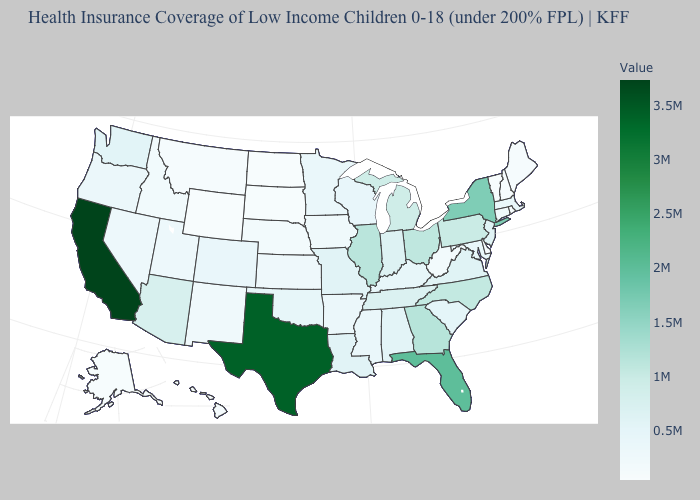Among the states that border Oregon , which have the highest value?
Give a very brief answer. California. Does Alaska have the highest value in the USA?
Keep it brief. No. 